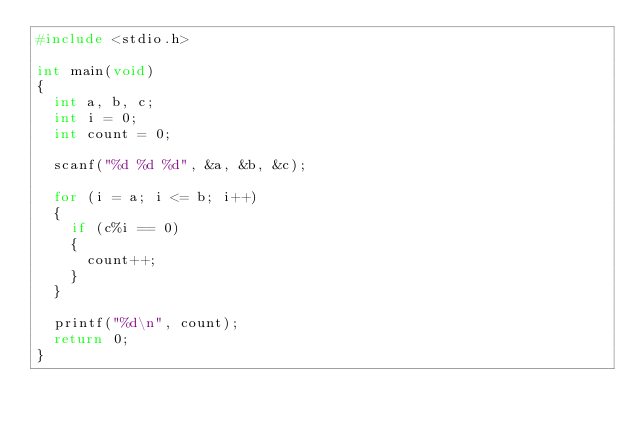<code> <loc_0><loc_0><loc_500><loc_500><_C_>#include <stdio.h>

int main(void)          
{
	int a, b, c;
	int i = 0;
	int count = 0;

	scanf("%d %d %d", &a, &b, &c);

	for (i = a; i <= b; i++) 
	{
		if (c%i == 0)
		{
			count++;
		}
	}

	printf("%d\n", count);
	return 0;
}</code> 